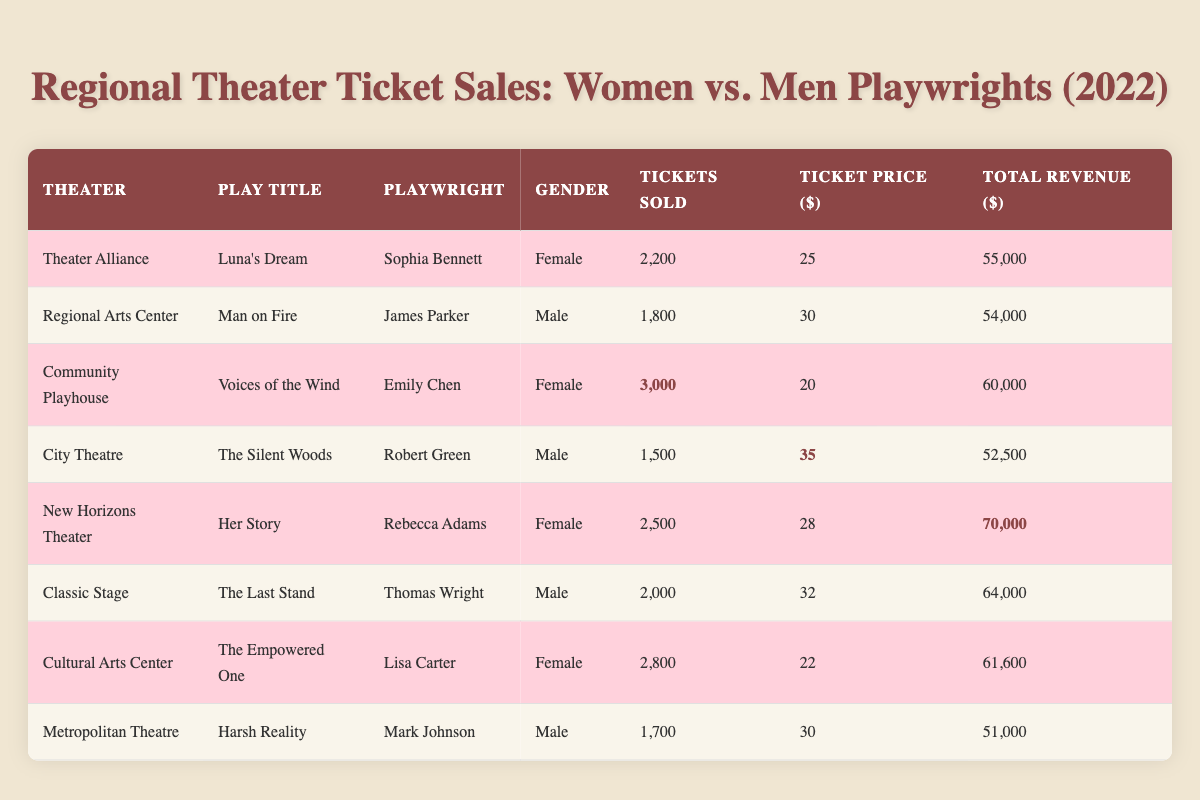What is the total number of tickets sold for plays written by female playwrights? There are three plays by female playwrights: "Luna's Dream" (2,200 tickets), "Voices of the Wind" (3,000 tickets), "Her Story" (2,500 tickets). Adding these together gives 2,200 + 3,000 + 2,500 = 7,700 tickets sold.
Answer: 7,700 Which play generated the highest total revenue? Looking at the total revenue for each play, "Her Story" by Rebecca Adams generated the highest revenue at $70,000.
Answer: $70,000 How many tickets were sold for the play "Man on Fire"? The play "Man on Fire," written by James Parker at the Regional Arts Center, sold a total of 1,800 tickets.
Answer: 1,800 What is the average ticket price for plays written by male playwrights? The plays by male playwrights have the following ticket prices: "Man on Fire" ($30), "The Silent Woods" ($35), "The Last Stand" ($32), and "Harsh Reality" ($30). The average ticket price is (30 + 35 + 32 + 30) / 4 = 31.75.
Answer: 31.75 Did "The Empowered One" sell more tickets than "The Silent Woods"? "The Empowered One," written by Lisa Carter, sold 2,800 tickets, while "The Silent Woods," written by Robert Green, sold 1,500 tickets. Since 2,800 is greater than 1,500, the statement is true.
Answer: Yes What is the total revenue generated by plays written by female playwrights? The total revenue for female playwrights is: "Luna's Dream" ($55,000) + "Voices of the Wind" ($60,000) + "Her Story" ($70,000) + "The Empowered One" ($61,600). Adding these gives $55,000 + $60,000 + $70,000 + $61,600 = $246,600.
Answer: $246,600 Which group (female or male playwrights) had the higher total ticket sales? Total ticket sales for female playwrights: 2,200 (Luna's Dream) + 3,000 (Voices of the Wind) + 2,500 (Her Story) + 2,800 (The Empowered One) = 10,500 tickets. For male playwrights: 1,800 (Man on Fire) + 1,500 (The Silent Woods) + 2,000 (The Last Stand) + 1,700 (Harsh Reality) = 7,000 tickets. Since 10,500 is greater than 7,000, female playwrights had higher total ticket sales.
Answer: Female playwrights What is the difference in total revenue between "Voices of the Wind" and "Harsh Reality"? "Voices of the Wind" generated $60,000 while "Harsh Reality" generated $51,000. The difference is $60,000 - $51,000 = $9,000.
Answer: $9,000 Which theater had the highest ticket sales? The theater with the highest ticket sales is the Community Playhouse with "Voices of the Wind," selling 3,000 tickets.
Answer: Community Playhouse What percentage of total tickets sold were from plays written by women? Total tickets sold from female playwrights = 7,700, total tickets sold = 7,700 (women) + 7,000 (men) = 14,700. The percentage is (7,700 / 14,700) * 100 = approximately 52.38%.
Answer: 52.38% 